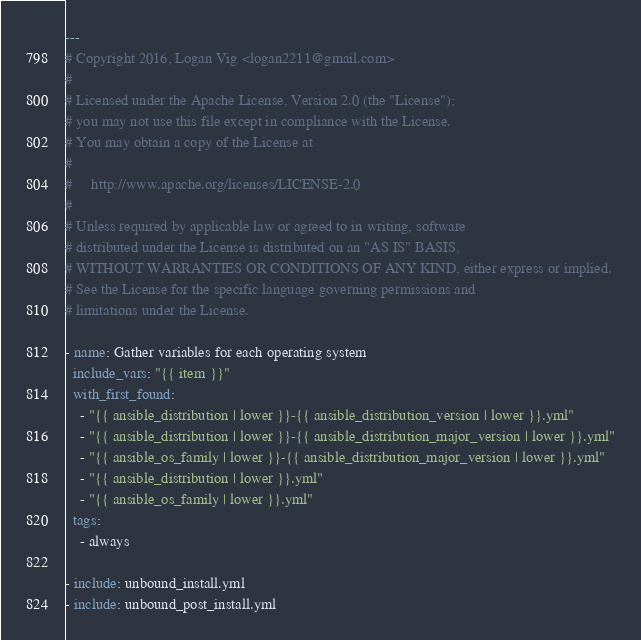<code> <loc_0><loc_0><loc_500><loc_500><_YAML_>---
# Copyright 2016, Logan Vig <logan2211@gmail.com>
#
# Licensed under the Apache License, Version 2.0 (the "License");
# you may not use this file except in compliance with the License.
# You may obtain a copy of the License at
#
#     http://www.apache.org/licenses/LICENSE-2.0
#
# Unless required by applicable law or agreed to in writing, software
# distributed under the License is distributed on an "AS IS" BASIS,
# WITHOUT WARRANTIES OR CONDITIONS OF ANY KIND, either express or implied.
# See the License for the specific language governing permissions and
# limitations under the License.

- name: Gather variables for each operating system
  include_vars: "{{ item }}"
  with_first_found:
    - "{{ ansible_distribution | lower }}-{{ ansible_distribution_version | lower }}.yml"
    - "{{ ansible_distribution | lower }}-{{ ansible_distribution_major_version | lower }}.yml"
    - "{{ ansible_os_family | lower }}-{{ ansible_distribution_major_version | lower }}.yml"
    - "{{ ansible_distribution | lower }}.yml"
    - "{{ ansible_os_family | lower }}.yml"
  tags:
    - always

- include: unbound_install.yml
- include: unbound_post_install.yml
</code> 